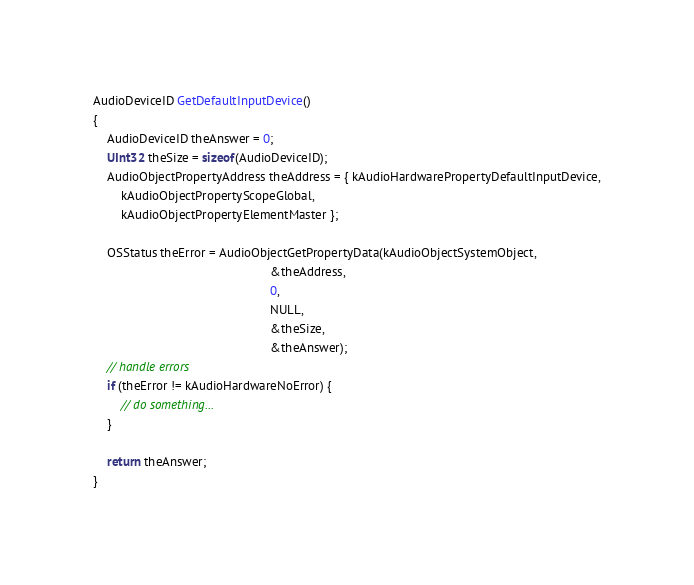<code> <loc_0><loc_0><loc_500><loc_500><_ObjectiveC_>
AudioDeviceID GetDefaultInputDevice()
{
    AudioDeviceID theAnswer = 0;
    UInt32 theSize = sizeof(AudioDeviceID);
    AudioObjectPropertyAddress theAddress = { kAudioHardwarePropertyDefaultInputDevice,
        kAudioObjectPropertyScopeGlobal,
        kAudioObjectPropertyElementMaster };
    
    OSStatus theError = AudioObjectGetPropertyData(kAudioObjectSystemObject,
                                                   &theAddress,
                                                   0,
                                                   NULL,
                                                   &theSize,
                                                   &theAnswer);
    // handle errors
    if (theError != kAudioHardwareNoError) {
        // do something...
    }
    
    return theAnswer;
}
</code> 